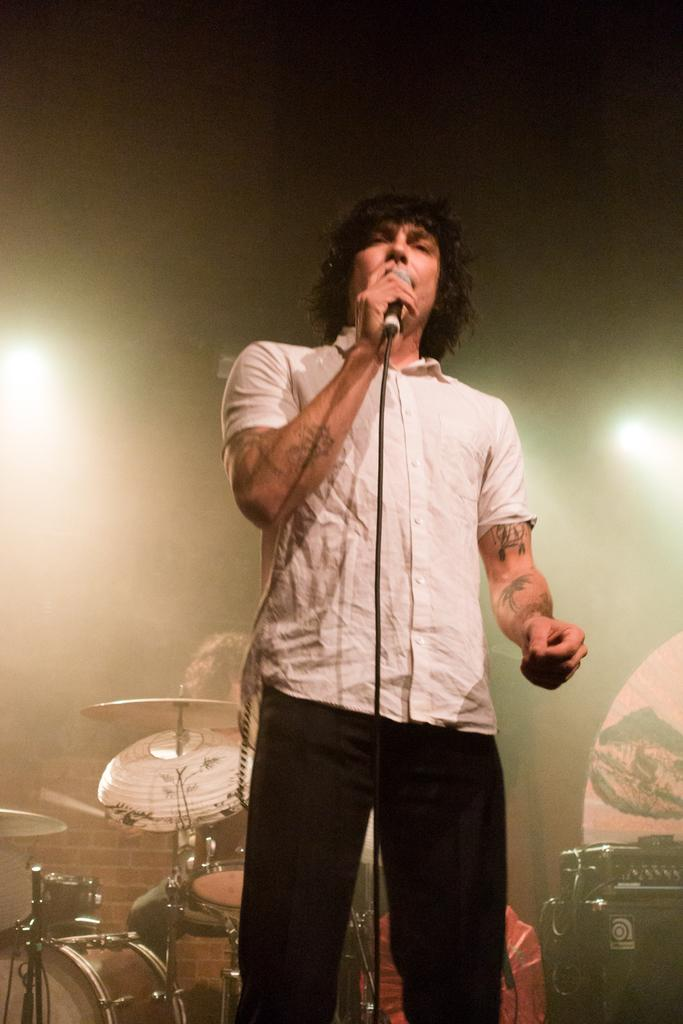How many people are in the image? There are two men in the image. What is one of the men doing in the image? One man is standing and holding a mic. What is near the other man in the image? The other man is near to the drums. What can be seen in the image besides the people? There is equipment and lights visible in the image. What type of skirt is the man wearing near the drums? There is no skirt present in the image, as both men are wearing pants. 